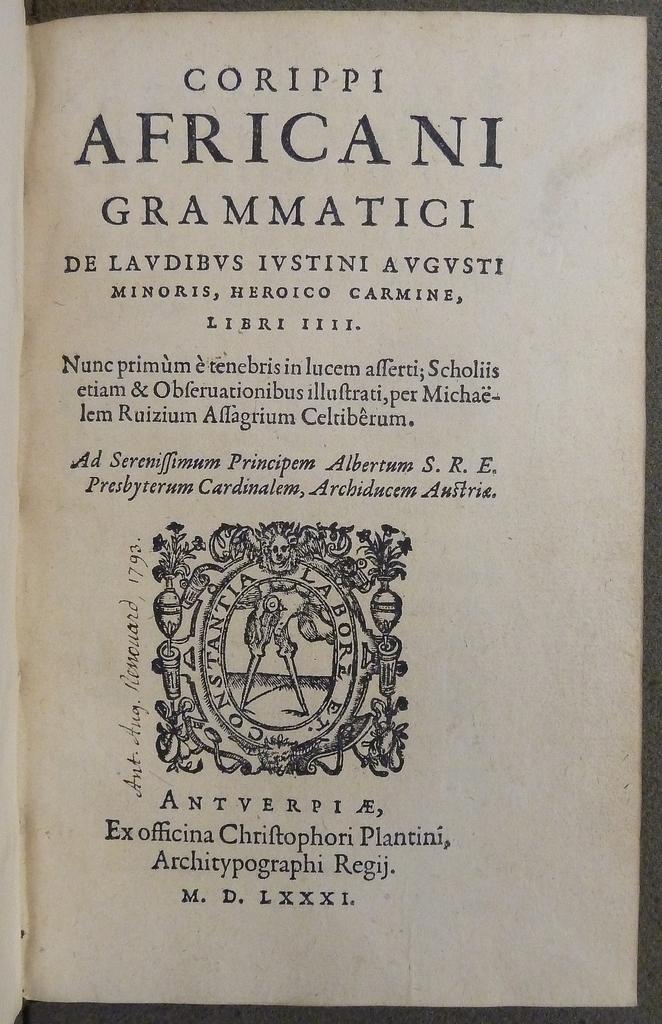What roman numerals are located at the bottom of the page?
Offer a terse response. Lxxxi. 